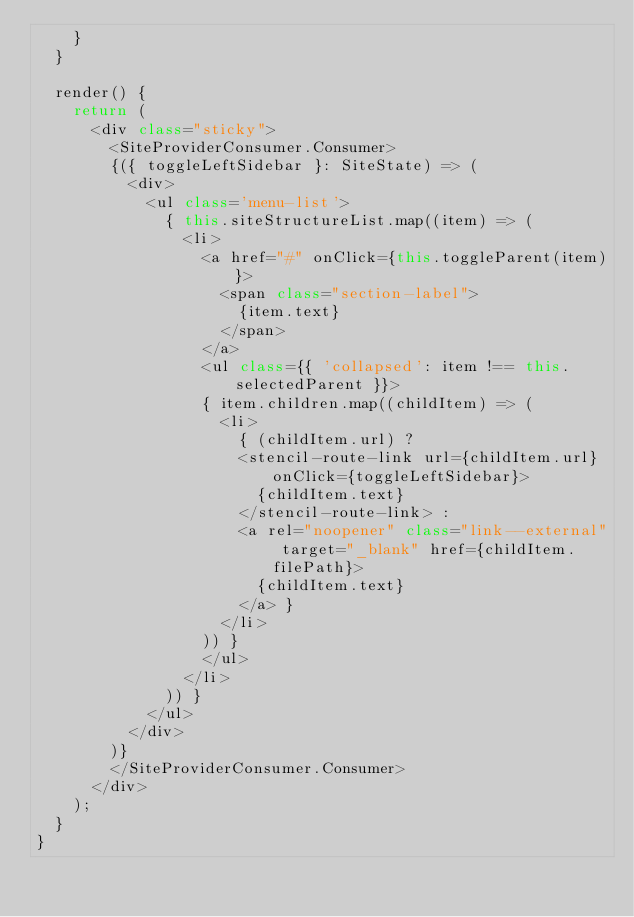Convert code to text. <code><loc_0><loc_0><loc_500><loc_500><_TypeScript_>    }
  }

  render() {
    return (
      <div class="sticky">
        <SiteProviderConsumer.Consumer>
        {({ toggleLeftSidebar }: SiteState) => (
          <div>
            <ul class='menu-list'>
              { this.siteStructureList.map((item) => (
                <li>
                  <a href="#" onClick={this.toggleParent(item)}>
                    <span class="section-label">
                      {item.text}
                    </span>
                  </a>
                  <ul class={{ 'collapsed': item !== this.selectedParent }}>
                  { item.children.map((childItem) => (
                    <li>
                      { (childItem.url) ?
                      <stencil-route-link url={childItem.url} onClick={toggleLeftSidebar}>
                        {childItem.text}
                      </stencil-route-link> :
                      <a rel="noopener" class="link--external" target="_blank" href={childItem.filePath}>
                        {childItem.text}
                      </a> }
                    </li>
                  )) }
                  </ul>
                </li>
              )) }
            </ul>
          </div>
        )}
        </SiteProviderConsumer.Consumer>
      </div>
    );
  }
}
</code> 